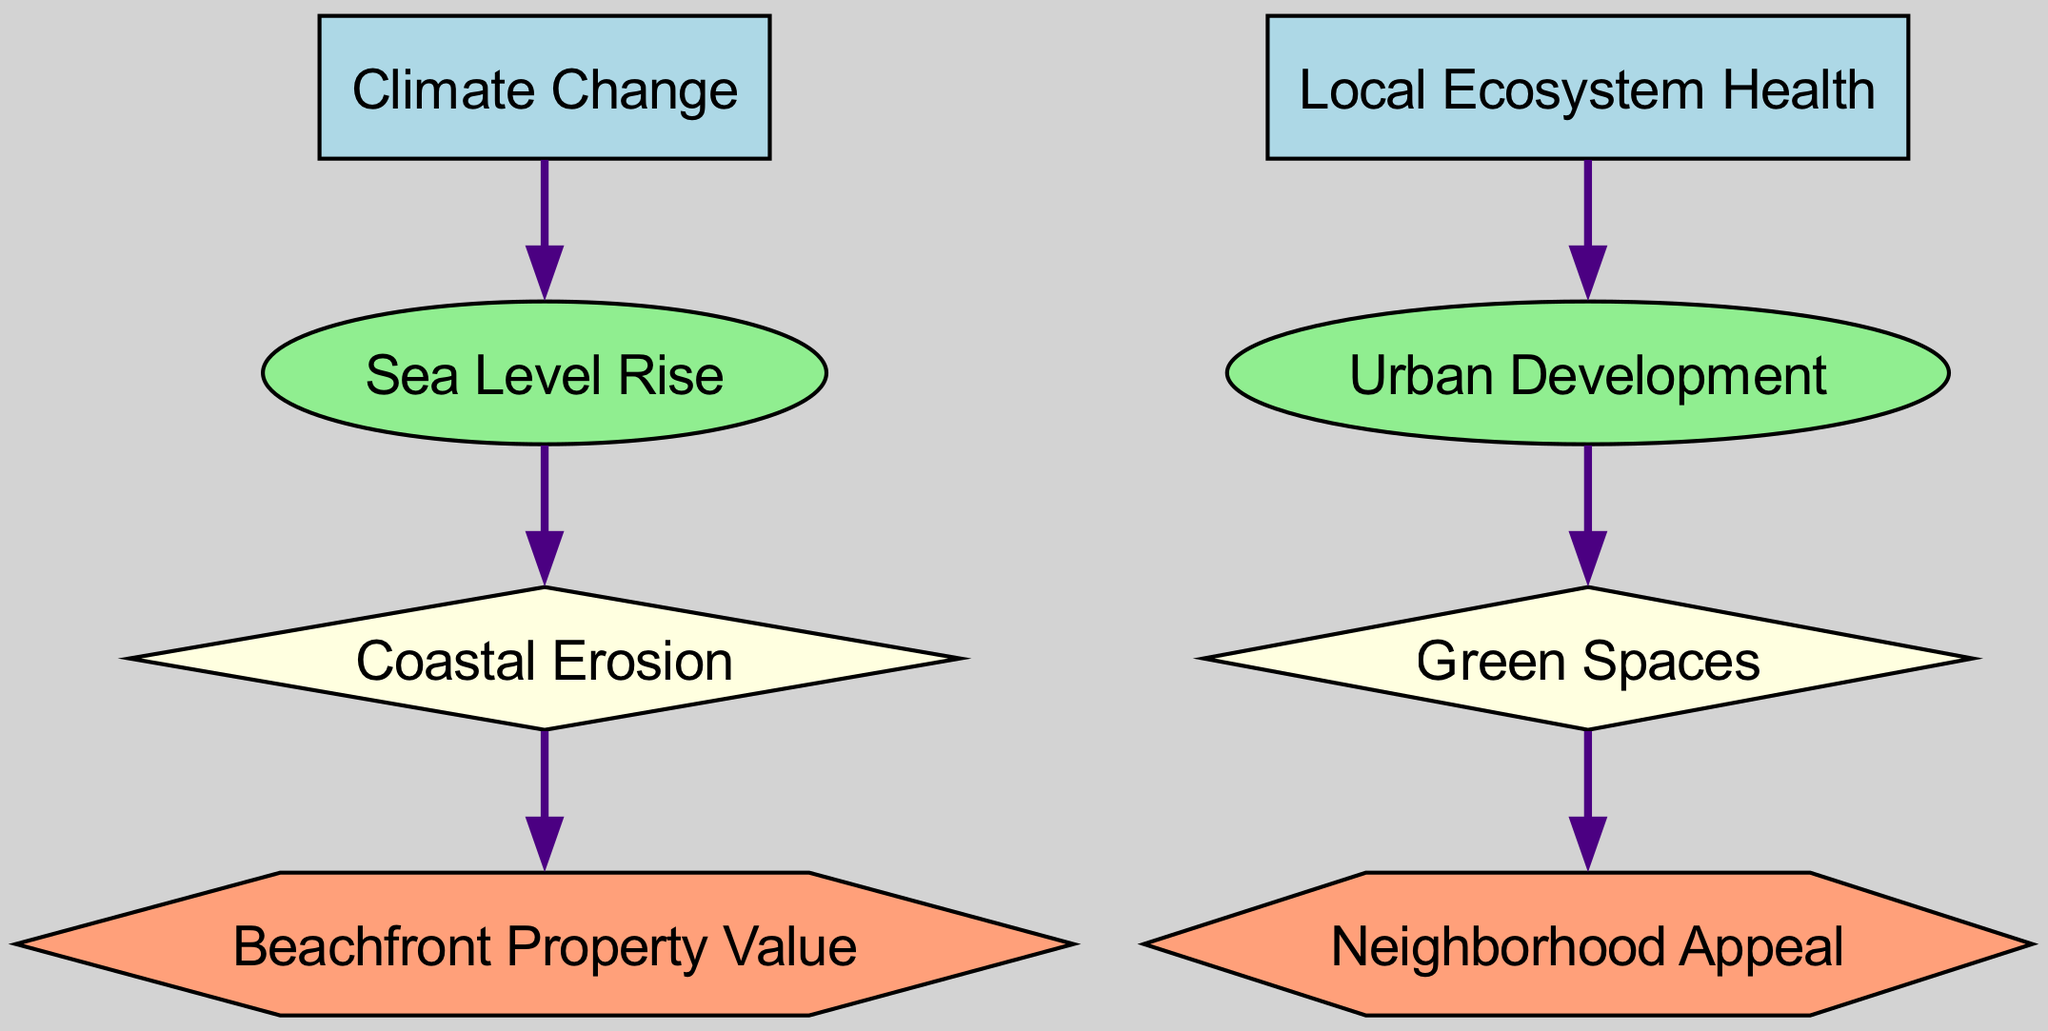What is the last node in the food chain? The last node is identified by looking at which element does not serve as a food source for any other element in the diagram. "Beachfront Property Value" and "Neighborhood Appeal" can be considered last nodes, but since "Beachfront Property Value" is further down the chain, it will be the last if we categorize based on the flow.
Answer: Beachfront Property Value How many primary consumers are there? Counting the nodes classified as primary consumers in the diagram, we find there are two: "Sea Level Rise" and "Urban Development." We arrive at this count by identifying the elements defined with the type "primary_consumer."
Answer: 2 What does coastal erosion eat? The dietary relationship can be determined by finding the element that has an "eats" connection pointing to "coastal erosion." The diagram clearly specifies that "Sea Level Rise" is being consumed, indicating coastal erosion's source of energy.
Answer: Sea Level Rise Which element directly affects neighborhood appeal? By tracing the flow of consumption in the diagram, "Green Spaces" is the element that feeds into "Neighborhood Appeal," meaning it must be considered vital for its value. This is determined by identifying where the arrows point from "green_spaces" to "neighborhood_appeal."
Answer: Green Spaces What is the relationship between climate change and beachfront property value? To understand this relationship, we follow the path in the diagram that begins with "Climate Change" and ends with "Beachfront Property Value." The pathway through "Sea Level Rise" and "Coastal Erosion" indicates that the changes in climate indirectly impact real estate by way of these intermediaries. This requires visualizing the chain of consumers.
Answer: Indirect through Sea Level Rise and Coastal Erosion How many producers are there in the diagram? Producers are signified by the nodes that do not get consumed by other elements. In this food chain, "Climate Change" and "Local Ecosystem Health" are the two producers present. We confirm this by identifying the elements with the type "producer."
Answer: 2 What is the first element in the food chain? To find the first element, we look for the producer that does not have any arrows pointing to it from other elements. "Climate Change" is at the starting point in this diagram. This element initiates the food chain.
Answer: Climate Change Which node is affected by urban development? Urban development directly influences "Green Spaces," as shown in the diagram by the arrow pointing from "Urban Development" to "Green Spaces." Thus, determining the flow establishes which node is affected.
Answer: Green Spaces 